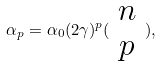Convert formula to latex. <formula><loc_0><loc_0><loc_500><loc_500>\alpha _ { p } = \alpha _ { 0 } ( 2 \gamma ) ^ { p } ( \begin{array} { c } n \\ p \end{array} ) ,</formula> 